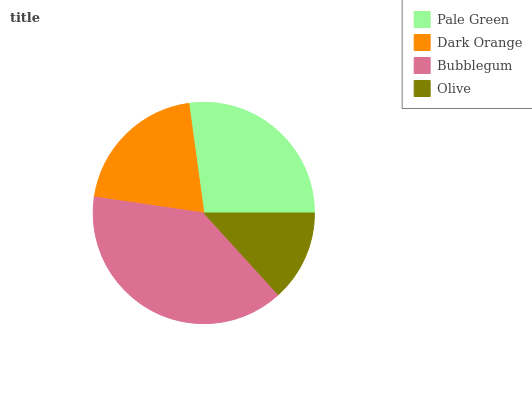Is Olive the minimum?
Answer yes or no. Yes. Is Bubblegum the maximum?
Answer yes or no. Yes. Is Dark Orange the minimum?
Answer yes or no. No. Is Dark Orange the maximum?
Answer yes or no. No. Is Pale Green greater than Dark Orange?
Answer yes or no. Yes. Is Dark Orange less than Pale Green?
Answer yes or no. Yes. Is Dark Orange greater than Pale Green?
Answer yes or no. No. Is Pale Green less than Dark Orange?
Answer yes or no. No. Is Pale Green the high median?
Answer yes or no. Yes. Is Dark Orange the low median?
Answer yes or no. Yes. Is Bubblegum the high median?
Answer yes or no. No. Is Pale Green the low median?
Answer yes or no. No. 